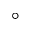<formula> <loc_0><loc_0><loc_500><loc_500>^ { \circ }</formula> 